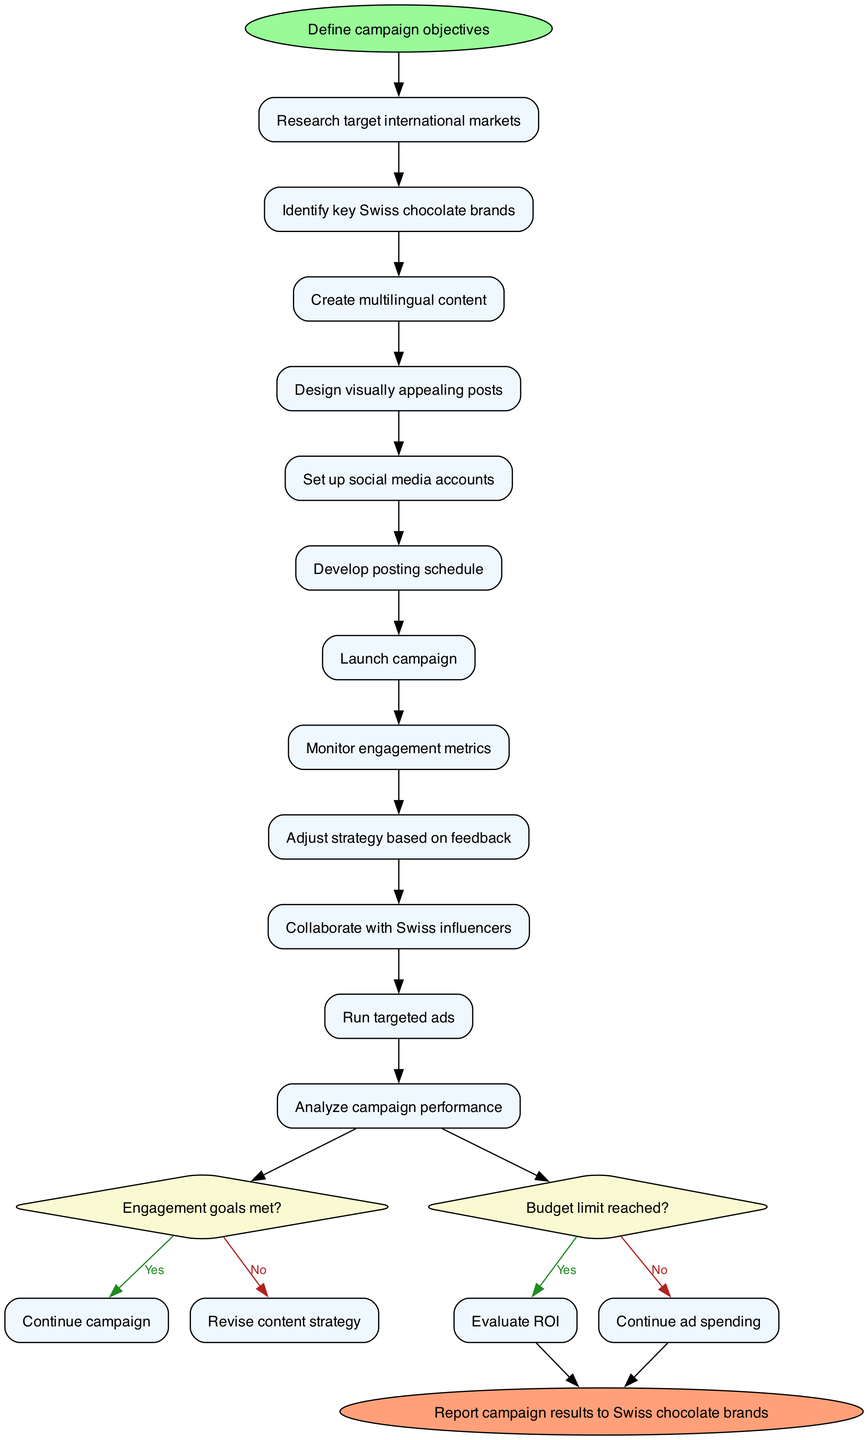what is the first activity in the diagram? The first activity is indicated after the start node, which points to "Research target international markets" as the first process in the flow.
Answer: Research target international markets how many decision nodes are there? By counting the decision nodes labeled in the diagram, there are a total of two decision nodes that evaluate specific conditions related to the campaign.
Answer: 2 what happens if the engagement goals are met? If the engagement goals are met as indicated in the flow, the process continues to the next step, which suggests to "Continue campaign".
Answer: Continue campaign what is the last activity before the end node? The last activity before reaching the end node in the diagram is "Analyze campaign performance," which is the final step before reporting the results.
Answer: Analyze campaign performance what is the action taken when the budget limit is reached? When the budget limit is reached according to the decision node, the action directed is to "Evaluate ROI,” which signifies the need to assess return on investment at that point.
Answer: Evaluate ROI what do we do if the engagement goals are not met? If the engagement goals are not met, the diagram indicates we "Revise content strategy," implying adjustments to the current strategy are required to improve engagement.
Answer: Revise content strategy how many total activities are outlined in this workflow? The diagram enumerates a total of twelve activities that outline the entire workflow from start to finish in promoting Swiss chocolate.
Answer: 12 how do you transition from "Launch campaign" to a decision node? The transition from "Launch campaign" to the first decision node happens directly, indicating a sequential movement where the outcome of the launch informs further actions based on engagement metrics.
Answer: Direct transition what is indicated by the start node in this diagram? The start node signifies the initial step of the campaign workflow, which is to "Define campaign objectives," setting the direction for all subsequent activities.
Answer: Define campaign objectives 